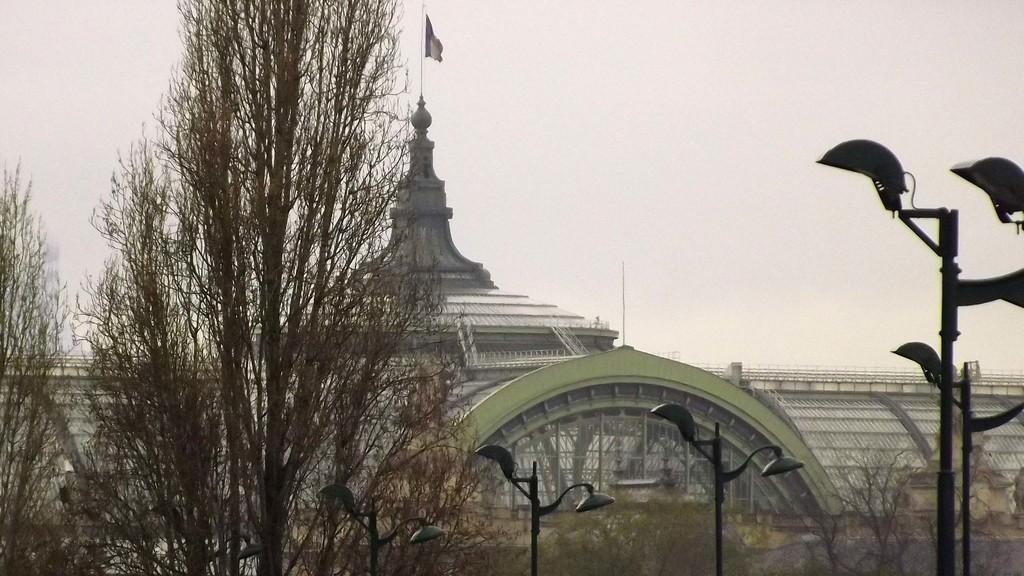How would you summarize this image in a sentence or two? In this image there are trees, light poles, in the background there is an architecture and the sky. 